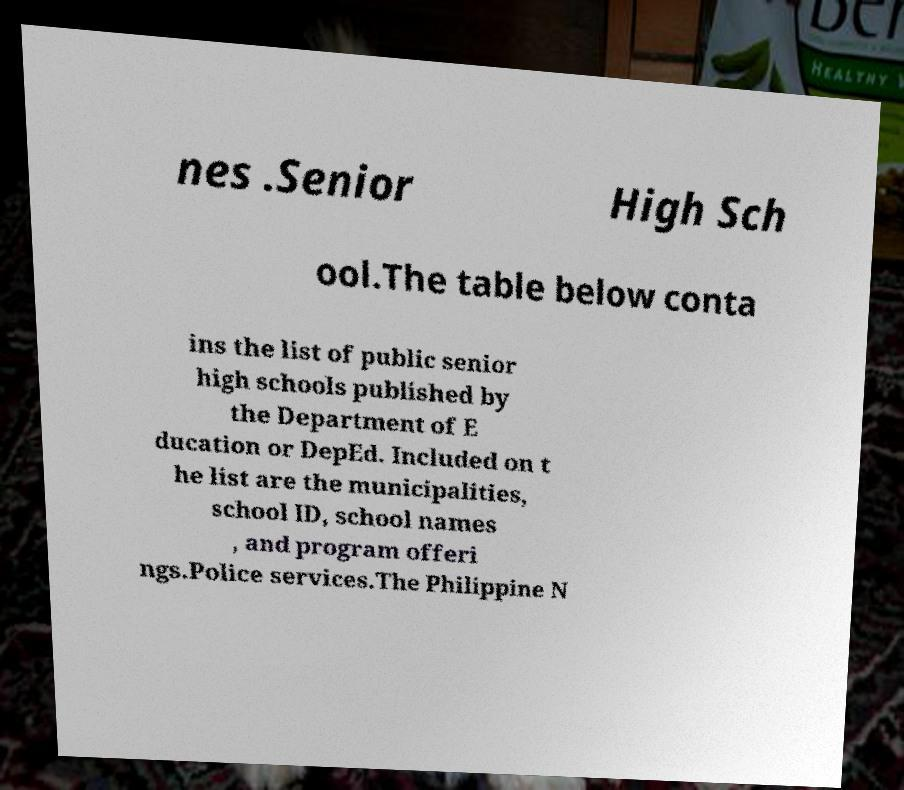Please identify and transcribe the text found in this image. nes .Senior High Sch ool.The table below conta ins the list of public senior high schools published by the Department of E ducation or DepEd. Included on t he list are the municipalities, school ID, school names , and program offeri ngs.Police services.The Philippine N 